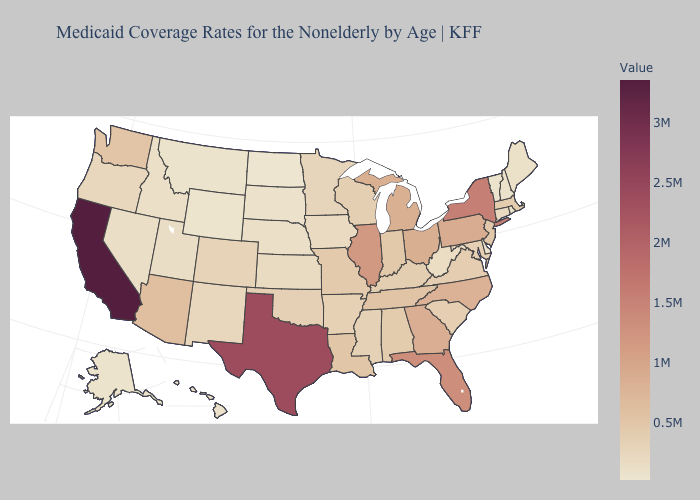Does North Dakota have the lowest value in the USA?
Concise answer only. Yes. Which states have the lowest value in the South?
Short answer required. Delaware. Among the states that border Nebraska , which have the highest value?
Short answer required. Missouri. Does Alabama have a higher value than Pennsylvania?
Give a very brief answer. No. Among the states that border Kentucky , does Tennessee have the highest value?
Give a very brief answer. No. Among the states that border Maryland , which have the highest value?
Concise answer only. Pennsylvania. Which states have the highest value in the USA?
Keep it brief. California. Among the states that border Indiana , does Michigan have the lowest value?
Keep it brief. No. Is the legend a continuous bar?
Keep it brief. Yes. 